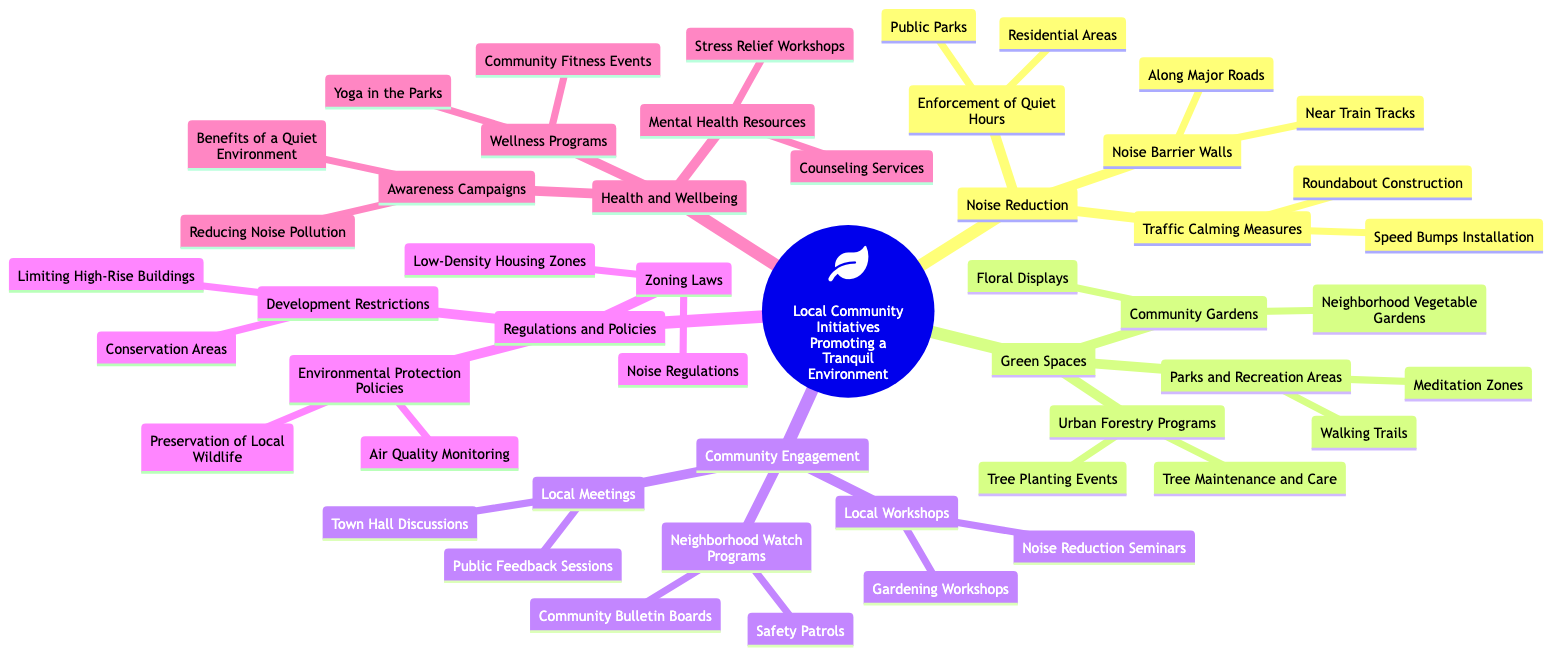What are two measures included in Noise Reduction? The central node for Noise Reduction lists two categories: Traffic Calming Measures and Noise Barrier Walls. Within Traffic Calming Measures, "Speed Bumps Installation" and "Roundabout Construction" are mentioned.
Answer: Speed Bumps Installation, Roundabout Construction How many Health and Wellbeing initiatives are listed? The Health and Wellbeing section includes three initiatives: Mental Health Resources, Wellness Programs, and Awareness Campaigns. Thus, the count is simply three based on these listed categories.
Answer: 3 What is the primary focus of the Regulations and Policies node? The Regulations and Policies node consists of three child nodes: Zoning Laws, Development Restrictions, and Environmental Protection Policies. Each of these nodes addresses aspects of urban planning and environmental conservation, indicating the overall focus on regulation.
Answer: Regulation Which community engagement initiative offers safety patrols? The Neighborhood Watch Programs child node contains "Safety Patrols," which is the initiative specifically focusing on community safety.
Answer: Safety Patrols What type of areas are emphasized in the Green Spaces section? The Green Spaces section highlights Community Gardens, Urban Forestry Programs, and Parks and Recreation Areas, signifying the importance of both green and recreational spaces in the community.
Answer: Community Gardens, Urban Forestry Programs, Parks and Recreation Areas What is one way to promote mental health listed under Health and Wellbeing? The Mental Health Resources node mentions "Counseling Services" as a specific initiative that supports mental health within the community.
Answer: Counseling Services What are the two types of traffic calming measures mentioned? Under the Traffic Calming Measures node, there are "Speed Bumps Installation" and "Roundabout Construction," which are specific interventions designed to reduce traffic speed and enhance safety.
Answer: Speed Bumps Installation, Roundabout Construction Which area includes meditation zones? Within the Parks and Recreation Areas, the element "Meditation Zones" is specifically included, indicating a designated space for meditation in the community.
Answer: Meditation Zones How many noise reduction strategies are mentioned? The Noise Reduction category lists three main strategies: Traffic Calming Measures, Noise Barrier Walls, and Enforcement of Quiet Hours, giving a total of three distinct strategies.
Answer: 3 